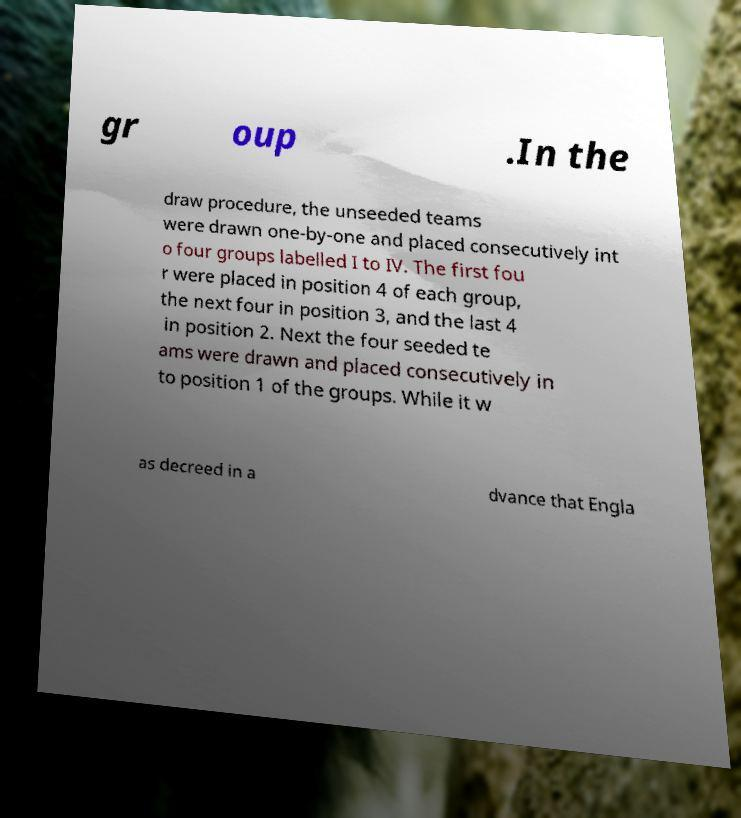Can you accurately transcribe the text from the provided image for me? gr oup .In the draw procedure, the unseeded teams were drawn one-by-one and placed consecutively int o four groups labelled I to IV. The first fou r were placed in position 4 of each group, the next four in position 3, and the last 4 in position 2. Next the four seeded te ams were drawn and placed consecutively in to position 1 of the groups. While it w as decreed in a dvance that Engla 